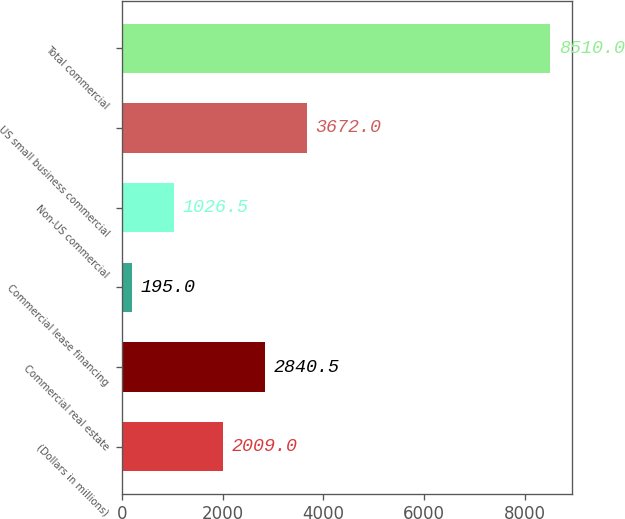Convert chart. <chart><loc_0><loc_0><loc_500><loc_500><bar_chart><fcel>(Dollars in millions)<fcel>Commercial real estate<fcel>Commercial lease financing<fcel>Non-US commercial<fcel>US small business commercial<fcel>Total commercial<nl><fcel>2009<fcel>2840.5<fcel>195<fcel>1026.5<fcel>3672<fcel>8510<nl></chart> 